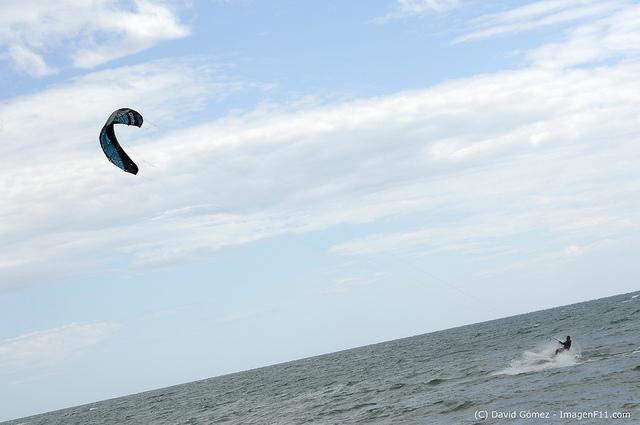Is she walking on water?
Be succinct. No. What sport is this?
Answer briefly. Parasailing. Is this sail moving with the wind?
Write a very short answer. Yes. 